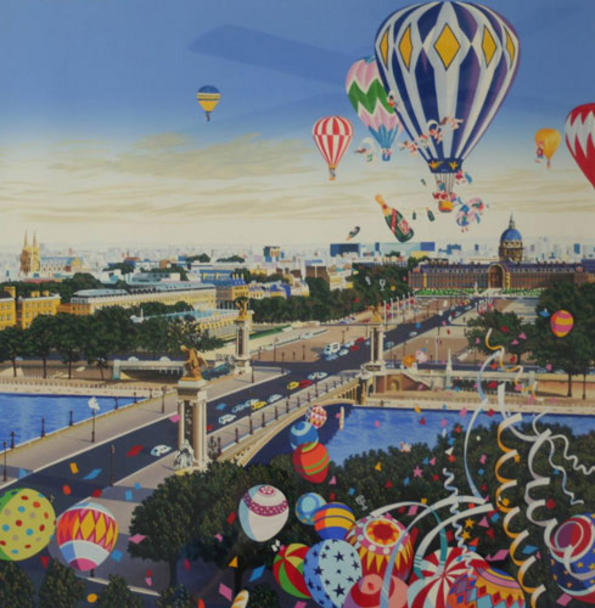Can you describe the different types of hot air balloons seen in the image? The image showcases a variety of hot air balloons, each distinct in design and color. Some notable examples include a large, dominant balloon with blue and yellow diamonds, resembling a diamond pattern, and several smaller balloons featuring stripes, polka dots, and checkered designs. Each balloon is meticulously detailed with vibrant colors, reflecting the overall whimsical and fantastical theme of the artwork. The diversity in designs and colors adds to the playful and imaginative feel of the scene. 